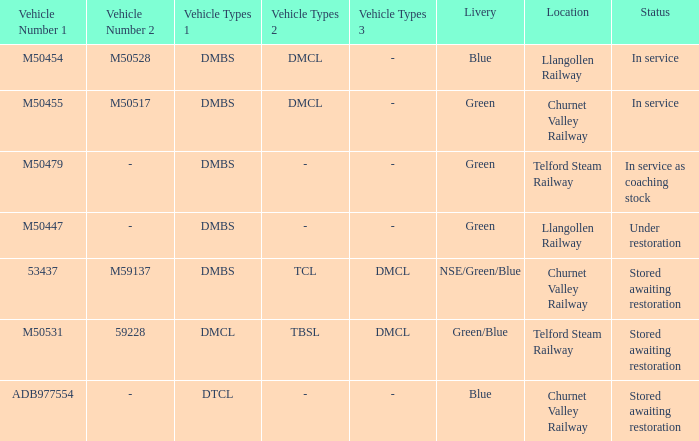What position are the vehicle types of dmbs+tcl+dmcl in? Stored awaiting restoration. 